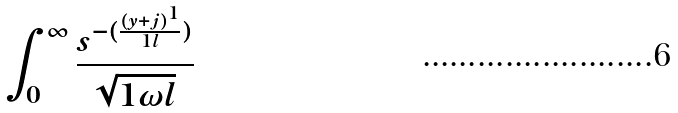Convert formula to latex. <formula><loc_0><loc_0><loc_500><loc_500>\int _ { 0 } ^ { \infty } \frac { s ^ { - ( \frac { ( y + j ) ^ { 1 } } { 1 l } ) } } { \sqrt { 1 \omega l } }</formula> 